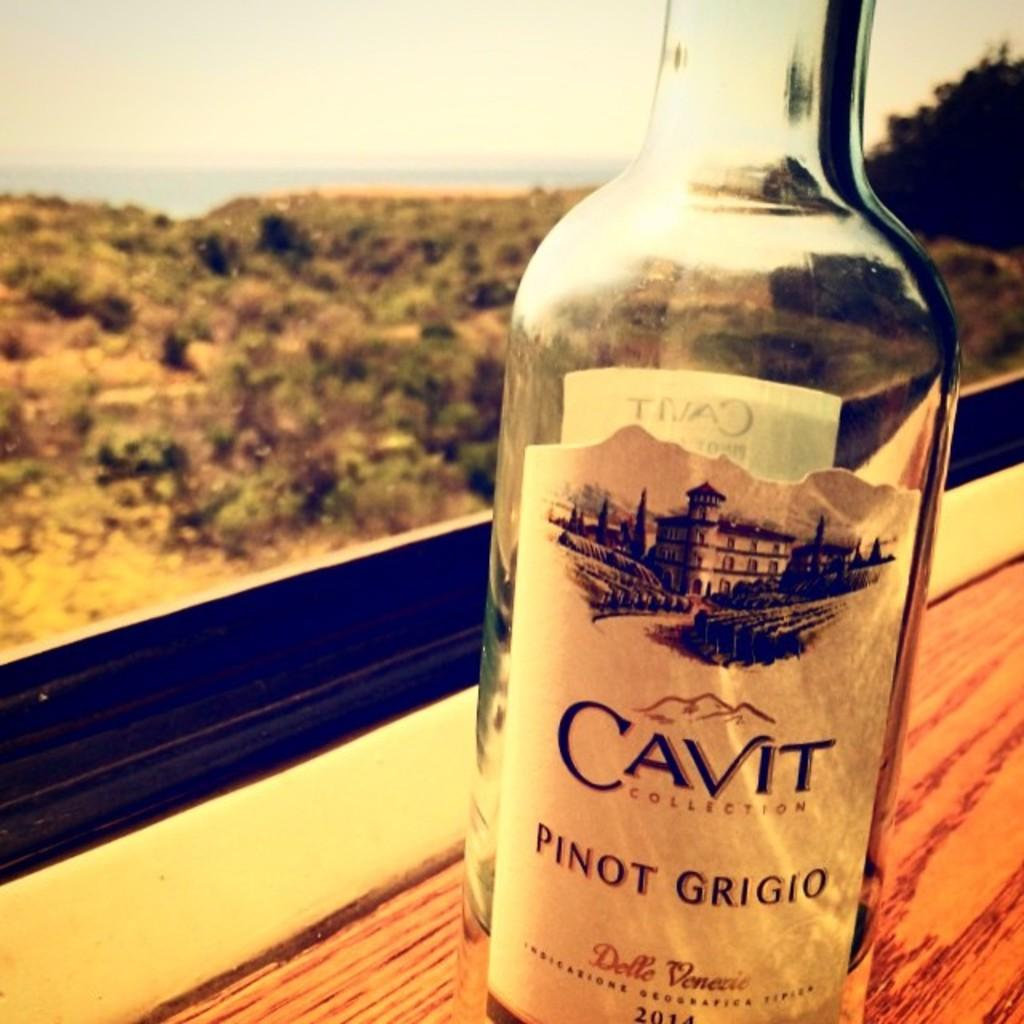<image>
Give a short and clear explanation of the subsequent image. A 1/4 full bottle of Cavit Collection Pinot Grigion in front of a window overlooking the desert. 